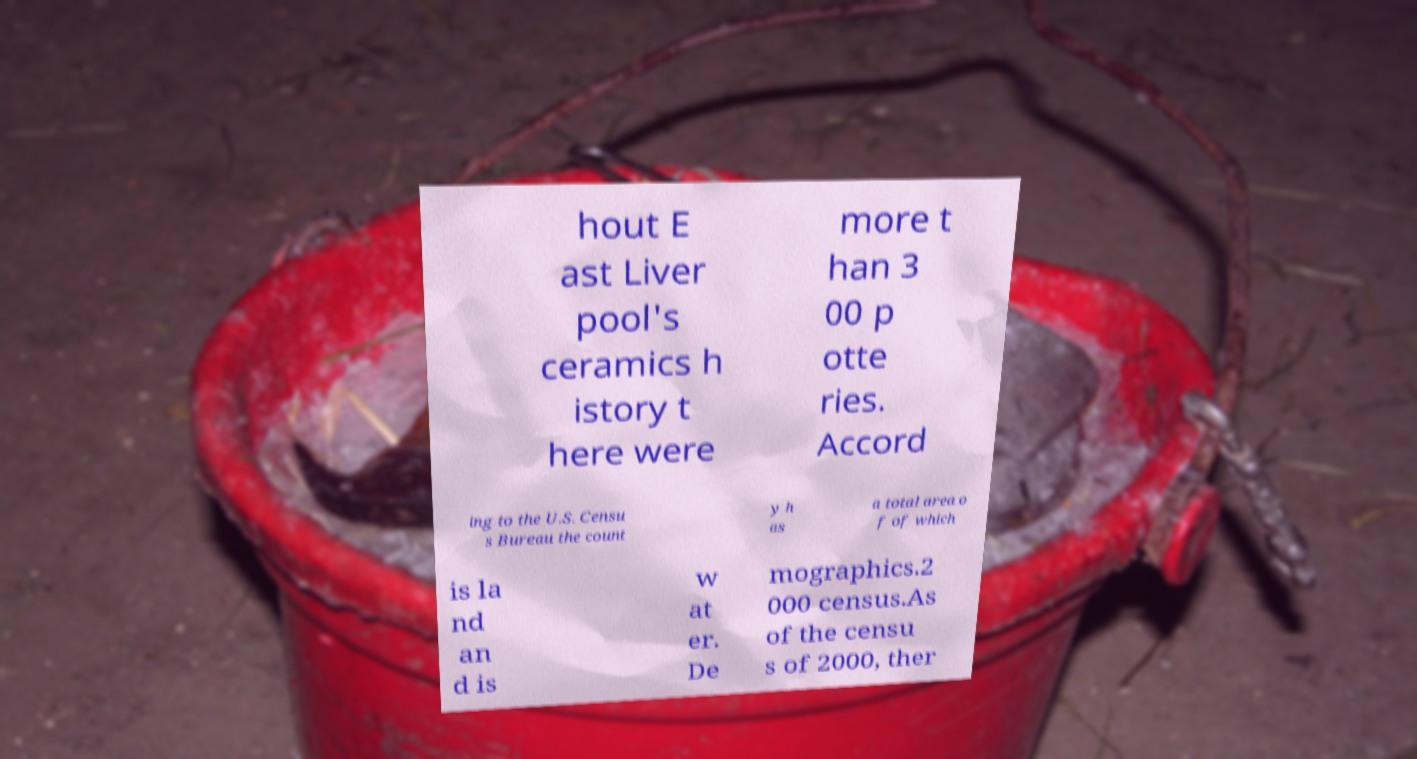What messages or text are displayed in this image? I need them in a readable, typed format. hout E ast Liver pool's ceramics h istory t here were more t han 3 00 p otte ries. Accord ing to the U.S. Censu s Bureau the count y h as a total area o f of which is la nd an d is w at er. De mographics.2 000 census.As of the censu s of 2000, ther 